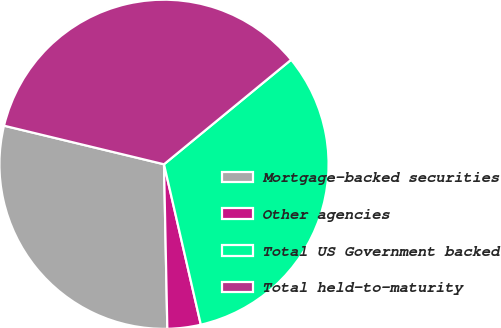Convert chart to OTSL. <chart><loc_0><loc_0><loc_500><loc_500><pie_chart><fcel>Mortgage-backed securities<fcel>Other agencies<fcel>Total US Government backed<fcel>Total held-to-maturity<nl><fcel>29.09%<fcel>3.27%<fcel>32.36%<fcel>35.28%<nl></chart> 